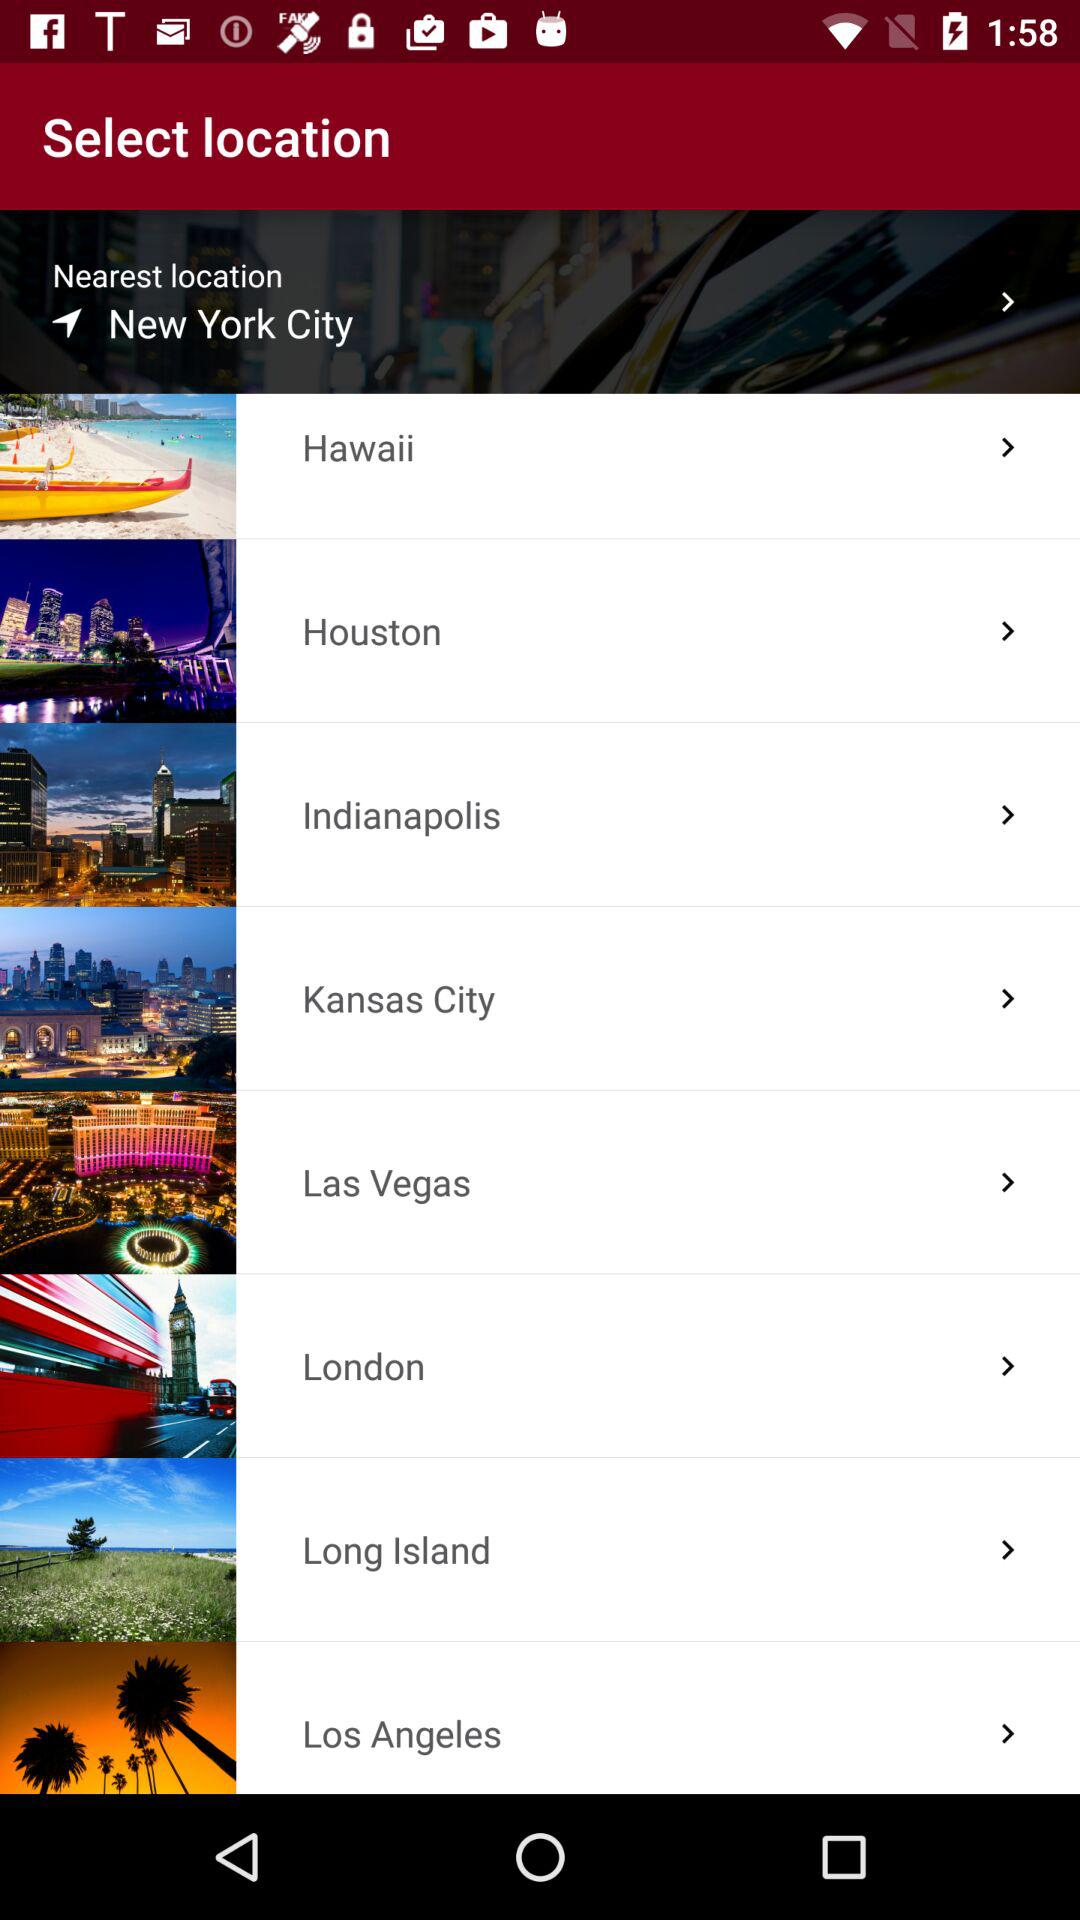What is the nearest location? The nearest location is New York City. 